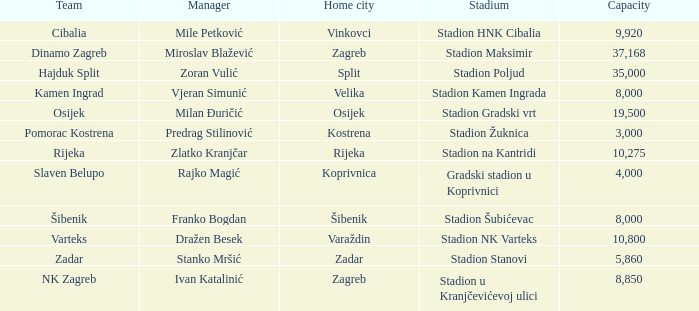What team that has a Home city of Zadar? Zadar. 